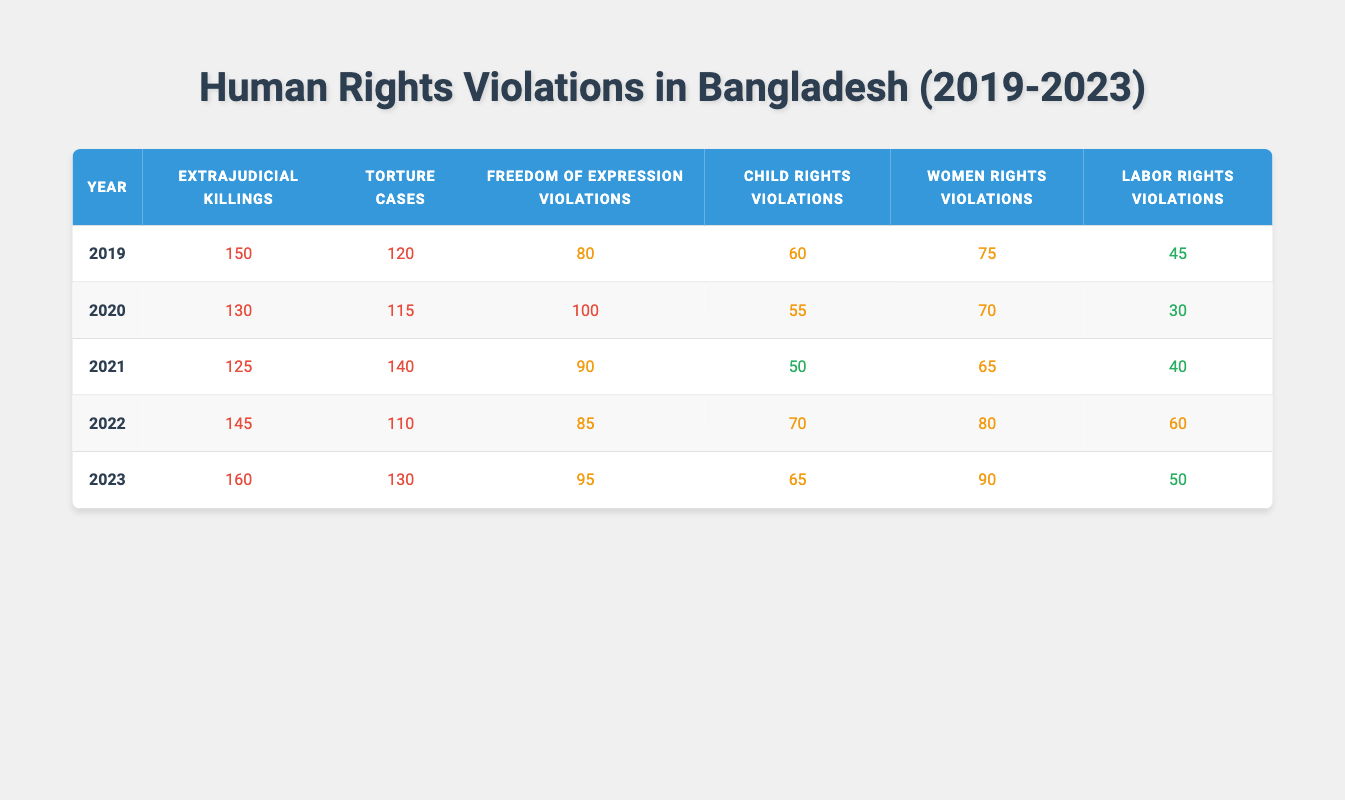What was the highest number of extrajudicial killings reported in a single year? The table shows that the highest number of extrajudicial killings was reported in 2023 with a count of 160, which is visibly the largest value in that column.
Answer: 160 Which year had the lowest number of labor rights violations? By examining the labor rights violations column, the year with the lowest count is 2020, which has 30 violations.
Answer: 30 What is the average number of torture cases reported from 2019 to 2023? To calculate the average, sum the torture cases: 120 + 115 + 140 + 110 + 130 = 615. There are 5 years, so the average is 615 / 5 = 123.
Answer: 123 Did the number of freedom of expression violations decrease from 2019 to 2022? In 2019, there were 80 violations, while in 2022, there were 85 violations. Since 85 is greater than 80, it indicates an increase, not a decrease.
Answer: No Which type of violation saw an increase each year from 2019 to 2023? Observing the values, extrajudicial killings increased each year: 150 (2019), 130 (2020), 125 (2021), 145 (2022), and 160 (2023). All subsequent years show a notable rise from the previous year, especially noted between 2021 and 2023.
Answer: Extrajudicial killings In which year was the total number of violations (all types) at its peak? Calculate the total violations for each year as follows: 
2019: 150 + 120 + 80 + 60 + 75 + 45 = 530, 
2020: 130 + 115 + 100 + 55 + 70 + 30 = 500, 
2021: 125 + 140 + 90 + 50 + 65 + 40 = 510, 
2022: 145 + 110 + 85 + 70 + 80 + 60 = 650, 
2023: 160 + 130 + 95 + 65 + 90 + 50 = 690. Thus, the peak year is 2023 with a total of 690 violations.
Answer: 2023 What was the ratio of women rights violations to child rights violations in 2021? For 2021, women rights violations are 65 and child rights violations are 50. The ratio is therefore 65:50, which simplifies to 13:10.
Answer: 13:10 Has the total number of human rights violations from 2019 to 2023 increased overall? Reviewing the totals for each year: 530 (2019), 500 (2020), 510 (2021), 650 (2022), and 690 (2023), there is a clear upward trend, especially from 2021 to 2023. The total definitely increased over these years.
Answer: Yes Which year had the highest number of women rights violations? Looking at the women rights violations column, it is clear that 2023 had the highest count with 90 violations.
Answer: 90 How many more torture cases were reported in 2021 compared to 2020? In 2021, there were 140 torture cases, and in 2020, there were 115. The difference is calculated by subtracting 115 from 140, leading to 25 more cases in 2021.
Answer: 25 What percentage of labor rights violations occurred in 2020 compared to the total violations that year? For 2020, the total number of violations was 500, and labor rights violations were 30. The percentage is (30 / 500) * 100 = 6%.
Answer: 6% 